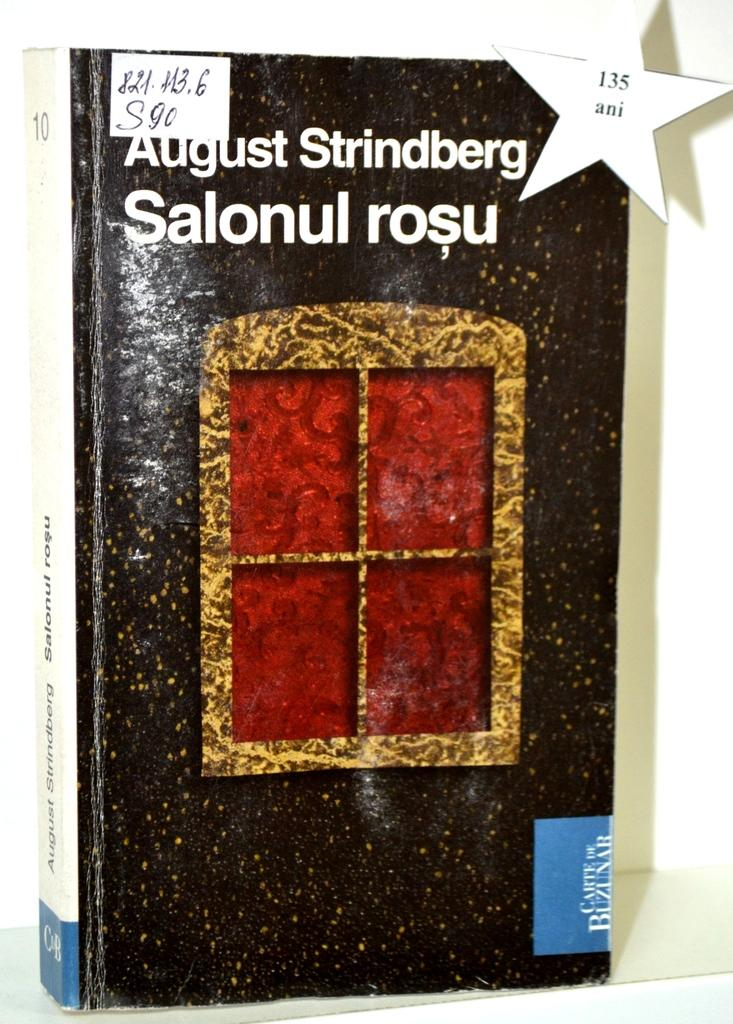<image>
Present a compact description of the photo's key features. A book by August Strindberg has a star on it with the number 135. 